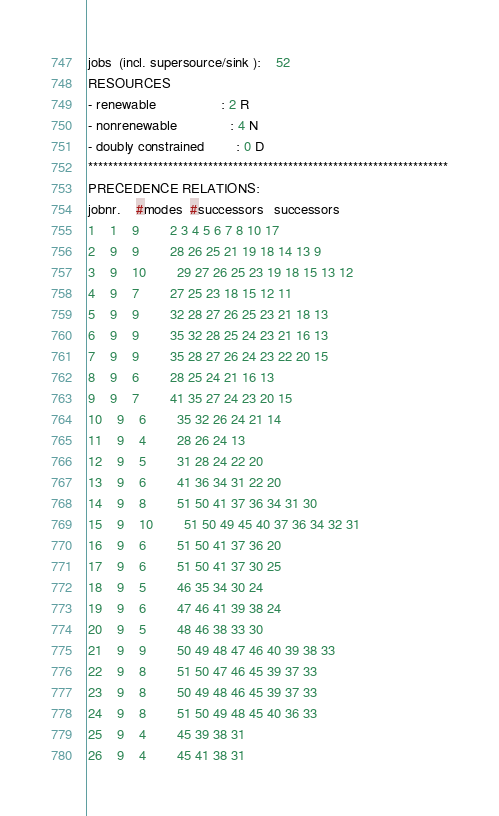Convert code to text. <code><loc_0><loc_0><loc_500><loc_500><_ObjectiveC_>jobs  (incl. supersource/sink ):	52
RESOURCES
- renewable                 : 2 R
- nonrenewable              : 4 N
- doubly constrained        : 0 D
************************************************************************
PRECEDENCE RELATIONS:
jobnr.    #modes  #successors   successors
1	1	9		2 3 4 5 6 7 8 10 17 
2	9	9		28 26 25 21 19 18 14 13 9 
3	9	10		29 27 26 25 23 19 18 15 13 12 
4	9	7		27 25 23 18 15 12 11 
5	9	9		32 28 27 26 25 23 21 18 13 
6	9	9		35 32 28 25 24 23 21 16 13 
7	9	9		35 28 27 26 24 23 22 20 15 
8	9	6		28 25 24 21 16 13 
9	9	7		41 35 27 24 23 20 15 
10	9	6		35 32 26 24 21 14 
11	9	4		28 26 24 13 
12	9	5		31 28 24 22 20 
13	9	6		41 36 34 31 22 20 
14	9	8		51 50 41 37 36 34 31 30 
15	9	10		51 50 49 45 40 37 36 34 32 31 
16	9	6		51 50 41 37 36 20 
17	9	6		51 50 41 37 30 25 
18	9	5		46 35 34 30 24 
19	9	6		47 46 41 39 38 24 
20	9	5		48 46 38 33 30 
21	9	9		50 49 48 47 46 40 39 38 33 
22	9	8		51 50 47 46 45 39 37 33 
23	9	8		50 49 48 46 45 39 37 33 
24	9	8		51 50 49 48 45 40 36 33 
25	9	4		45 39 38 31 
26	9	4		45 41 38 31 </code> 